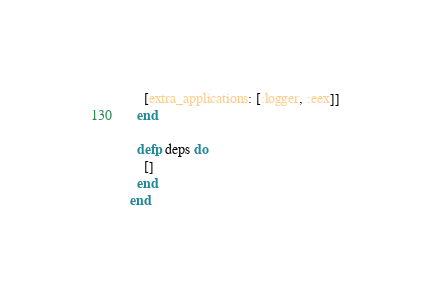Convert code to text. <code><loc_0><loc_0><loc_500><loc_500><_Elixir_>    [extra_applications: [:logger, :eex]]
  end

  defp deps do
    []
  end
end
</code> 